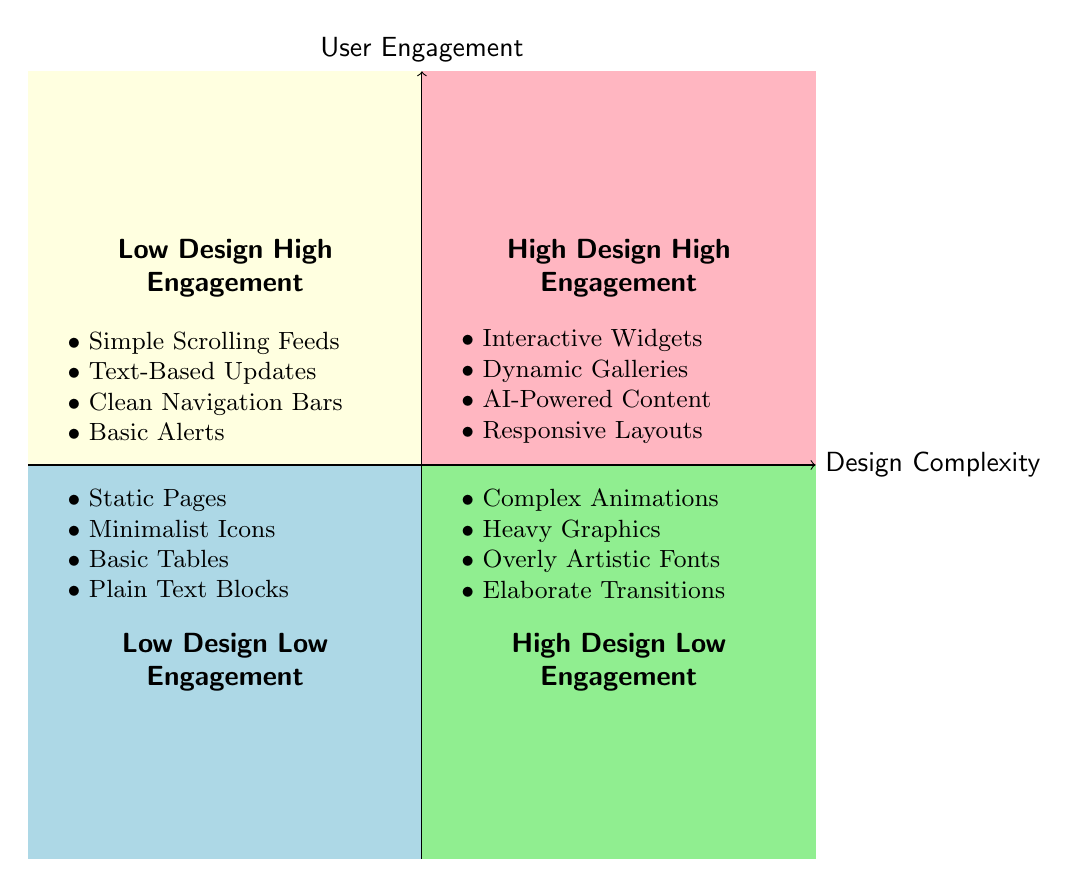What elements are found in the High Design High Engagement quadrant? The High Design High Engagement quadrant contains elements that include interactive features that enhance user engagement. These elements are listed in the quadrant section on the diagram, specifically pointing out widgets and galleries that are dynamic.
Answer: Interactive Widgets, Dynamic Galleries, AI-Powered Content Recommendations, Responsive Layouts Which quadrant contains Simple Scrolling Feeds? Simple Scrolling Feeds is an element that is categorized under Low Design High Engagement. This can be identified by locating the specific section of the diagram which classifies where this element falls based on its design complexity and user engagement levels.
Answer: Low Design High Engagement What kind of elements are listed in the High Design Low Engagement quadrant? The High Design Low Engagement quadrant lists elements that are visually complex yet fail to engage users effectively, which can be found by locating this specific area of the quadrant.
Answer: Complex Animations, Heavy Graphics, Overly Artistic Fonts, Elaborate Transitions How many examples are provided for the Low Design Low Engagement quadrant? The Low Design Low Engagement quadrant shows two specific examples: "Contact Information Pages" and "Static Policy Documents." By counting the provided example instances, we can determine the number.
Answer: 2 In which quadrant would you place AI-Powered Content Recommendations? AI-Powered Content Recommendations is an element categorized in the High Design High Engagement quadrant. This conclusion is drawn by checking the placement of the element in relation to its user engagement and design complexity classifications as shown in the diagram.
Answer: High Design High Engagement What is one of the examples listed under the Low Design High Engagement quadrant? An example listed for the Low Design High Engagement quadrant is "Event Calendars." This can be confirmed by directly referencing the examples indicated within that specific section of the diagram.
Answer: Event Calendars Which quadrant shows the most visually engaging elements? The quadrant showing the most visually engaging elements is the High Design High Engagement quadrant. This can be understood by evaluating the characteristics that define engagement and design complexity within the context of the diagram.
Answer: High Design High Engagement What design complexity level is associated with Static Pages? Static Pages are associated with Low Design complexity as seen in the Low Design Low Engagement quadrant where this element appears. The classification can be derived from the level of design indicated in that quadrant.
Answer: Low Design How many quadrants are shown in the diagram? The diagram contains a total of four distinct quadrants. This can be easily counted by checking the sections defined within the overall layout of the quadrant chart.
Answer: 4 